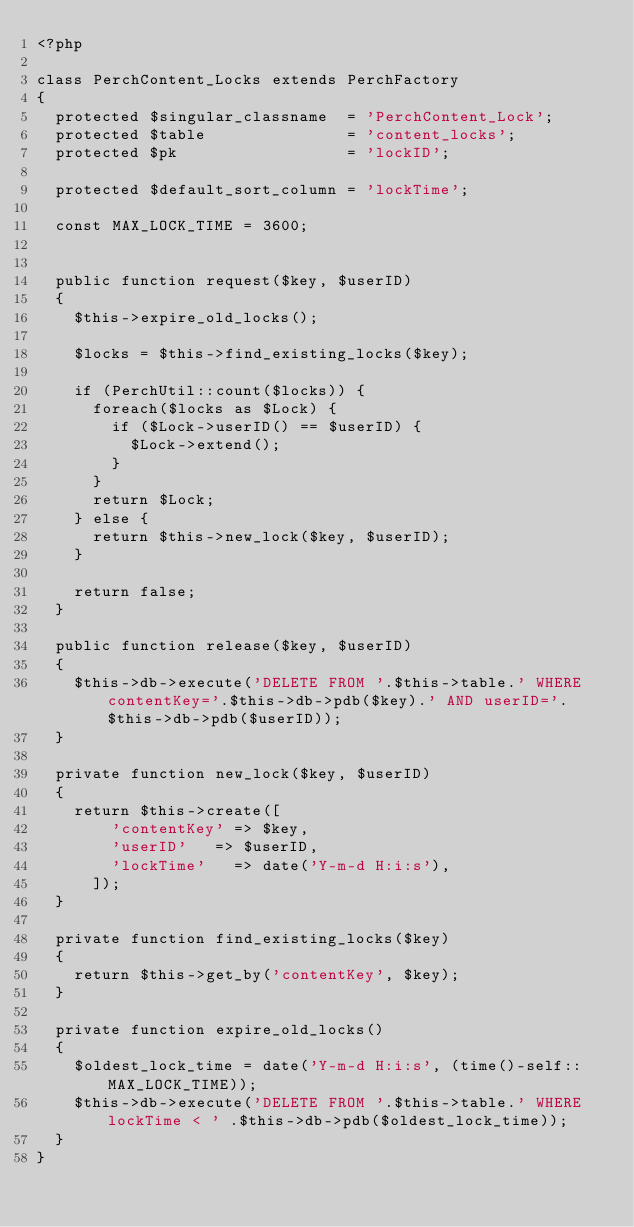<code> <loc_0><loc_0><loc_500><loc_500><_PHP_><?php 

class PerchContent_Locks extends PerchFactory
{
	protected $singular_classname  = 'PerchContent_Lock';
	protected $table               = 'content_locks';
	protected $pk                  = 'lockID';
	
	protected $default_sort_column = 'lockTime';  

	const MAX_LOCK_TIME = 3600;


	public function request($key, $userID)
	{
		$this->expire_old_locks();

		$locks = $this->find_existing_locks($key);

		if (PerchUtil::count($locks)) {
			foreach($locks as $Lock) {
				if ($Lock->userID() == $userID) {
					$Lock->extend();
				}
			}
			return $Lock;
		} else {
			return $this->new_lock($key, $userID);
		}

		return false;
	}

	public function release($key, $userID)
	{
		$this->db->execute('DELETE FROM '.$this->table.' WHERE contentKey='.$this->db->pdb($key).' AND userID='.$this->db->pdb($userID));
	}

	private function new_lock($key, $userID)
	{
		return $this->create([
				'contentKey' => $key,
				'userID'	 => $userID,
				'lockTime'	 => date('Y-m-d H:i:s'),
			]);
	}

	private function find_existing_locks($key)
	{
		return $this->get_by('contentKey', $key);
	}

	private function expire_old_locks()
	{
		$oldest_lock_time = date('Y-m-d H:i:s', (time()-self::MAX_LOCK_TIME));
		$this->db->execute('DELETE FROM '.$this->table.' WHERE lockTime < ' .$this->db->pdb($oldest_lock_time));
	}
}
</code> 